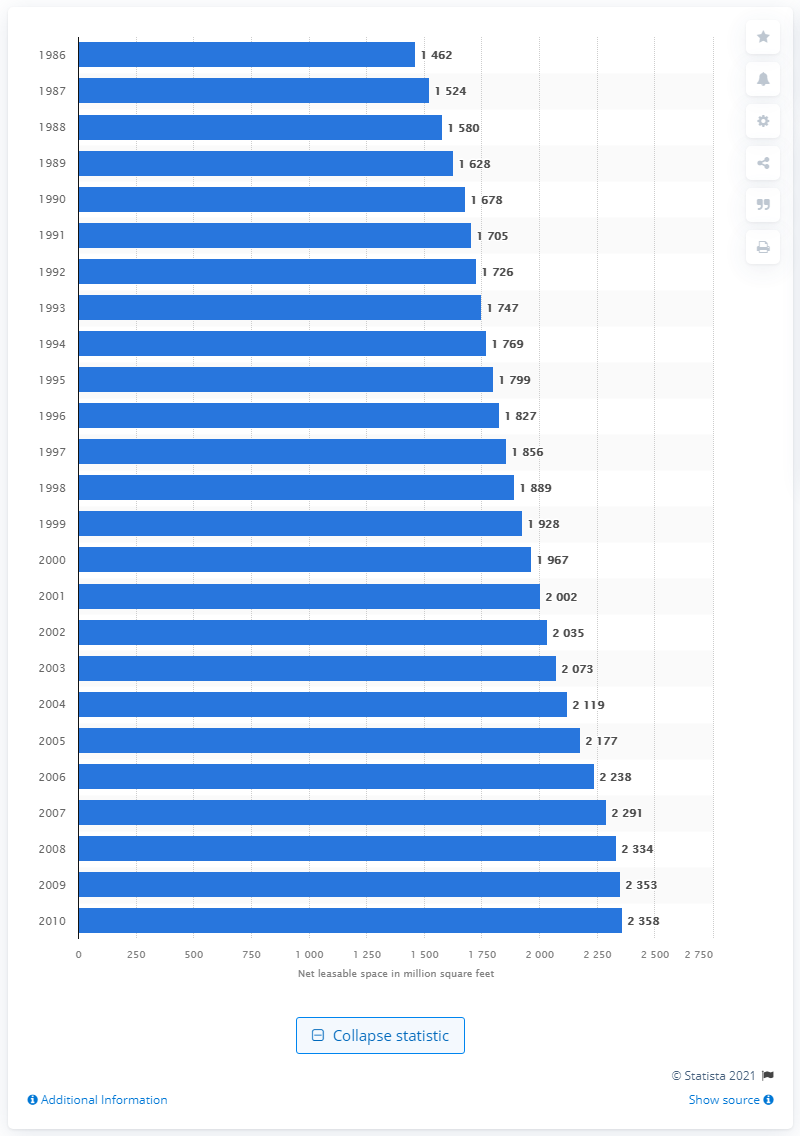Indicate a few pertinent items in this graphic. In the year 1986, small shopping malls in the United States had a total of 1,462 million square feet of leasable space. 